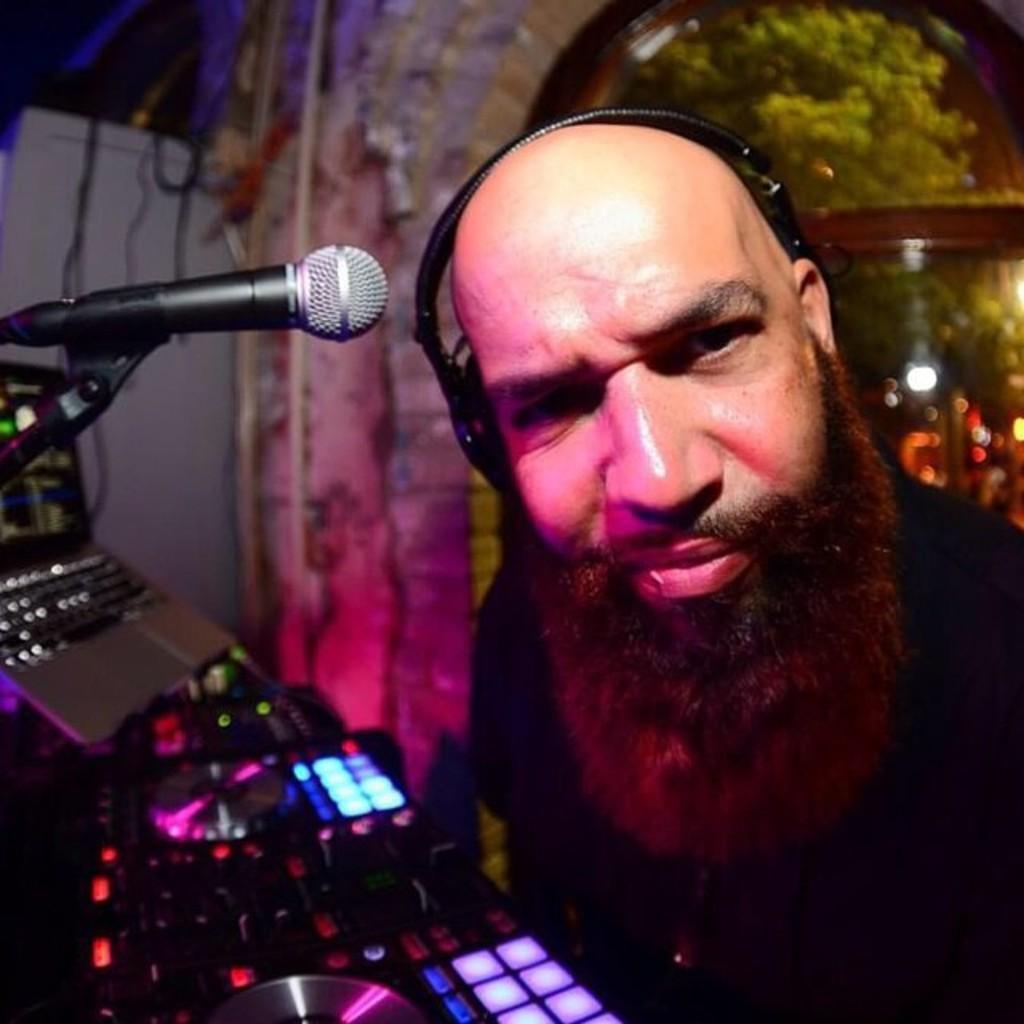In one or two sentences, can you explain what this image depicts? In this picture there is a man who is wearing headphones and black dress. In front of him we can see my, laptop, keyboard, CD and other objects on the table. In the back we can see door, trees and street light. Here we can see a darkness. 